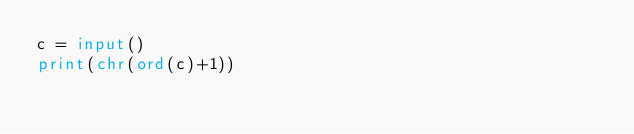<code> <loc_0><loc_0><loc_500><loc_500><_Python_>c = input()
print(chr(ord(c)+1))</code> 